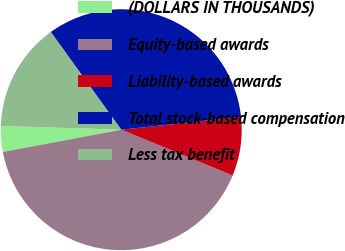<chart> <loc_0><loc_0><loc_500><loc_500><pie_chart><fcel>(DOLLARS IN THOUSANDS)<fcel>Equity-based awards<fcel>Liability-based awards<fcel>Total stock-based compensation<fcel>Less tax benefit<nl><fcel>3.46%<fcel>40.84%<fcel>7.9%<fcel>33.25%<fcel>14.55%<nl></chart> 